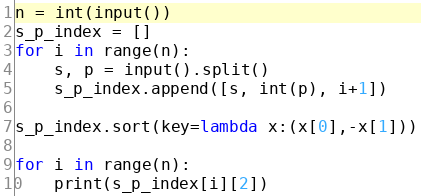Convert code to text. <code><loc_0><loc_0><loc_500><loc_500><_Python_>n = int(input())
s_p_index = []
for i in range(n):
    s, p = input().split()
    s_p_index.append([s, int(p), i+1])

s_p_index.sort(key=lambda x:(x[0],-x[1]))

for i in range(n):
    print(s_p_index[i][2])</code> 